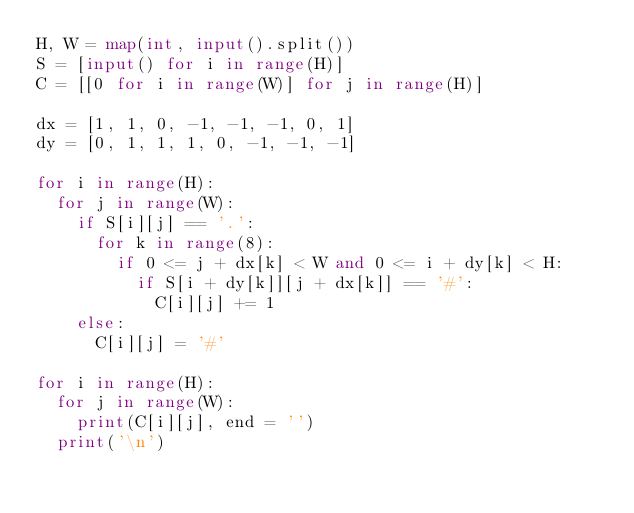<code> <loc_0><loc_0><loc_500><loc_500><_Python_>H, W = map(int, input().split())
S = [input() for i in range(H)]
C = [[0 for i in range(W)] for j in range(H)]
 
dx = [1, 1, 0, -1, -1, -1, 0, 1]
dy = [0, 1, 1, 1, 0, -1, -1, -1]
 
for i in range(H):
  for j in range(W):
    if S[i][j] == '.':
      for k in range(8):
        if 0 <= j + dx[k] < W and 0 <= i + dy[k] < H:
          if S[i + dy[k]][j + dx[k]] == '#':
            C[i][j] += 1
    else:
      C[i][j] = '#'
 
for i in range(H):
  for j in range(W):
    print(C[i][j], end = '')
  print('\n')</code> 